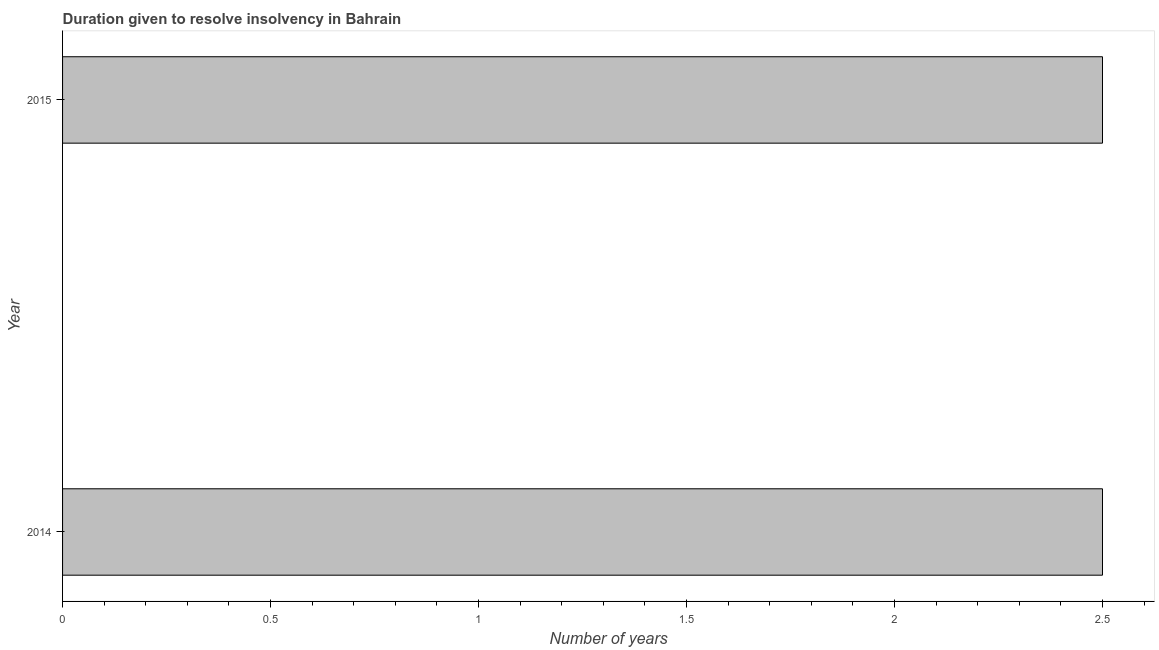Does the graph contain any zero values?
Your answer should be very brief. No. Does the graph contain grids?
Ensure brevity in your answer.  No. What is the title of the graph?
Your response must be concise. Duration given to resolve insolvency in Bahrain. What is the label or title of the X-axis?
Offer a terse response. Number of years. What is the number of years to resolve insolvency in 2014?
Make the answer very short. 2.5. Across all years, what is the minimum number of years to resolve insolvency?
Keep it short and to the point. 2.5. In which year was the number of years to resolve insolvency maximum?
Your answer should be compact. 2014. In which year was the number of years to resolve insolvency minimum?
Your response must be concise. 2014. What is the difference between the number of years to resolve insolvency in 2014 and 2015?
Ensure brevity in your answer.  0. What is the average number of years to resolve insolvency per year?
Offer a terse response. 2.5. What is the median number of years to resolve insolvency?
Your answer should be very brief. 2.5. In how many years, is the number of years to resolve insolvency greater than 0.9 ?
Your answer should be compact. 2. Do a majority of the years between 2015 and 2014 (inclusive) have number of years to resolve insolvency greater than 0.4 ?
Offer a very short reply. No. What is the ratio of the number of years to resolve insolvency in 2014 to that in 2015?
Your answer should be compact. 1. In how many years, is the number of years to resolve insolvency greater than the average number of years to resolve insolvency taken over all years?
Your answer should be very brief. 0. Are all the bars in the graph horizontal?
Offer a very short reply. Yes. What is the difference between two consecutive major ticks on the X-axis?
Your answer should be compact. 0.5. What is the ratio of the Number of years in 2014 to that in 2015?
Provide a succinct answer. 1. 